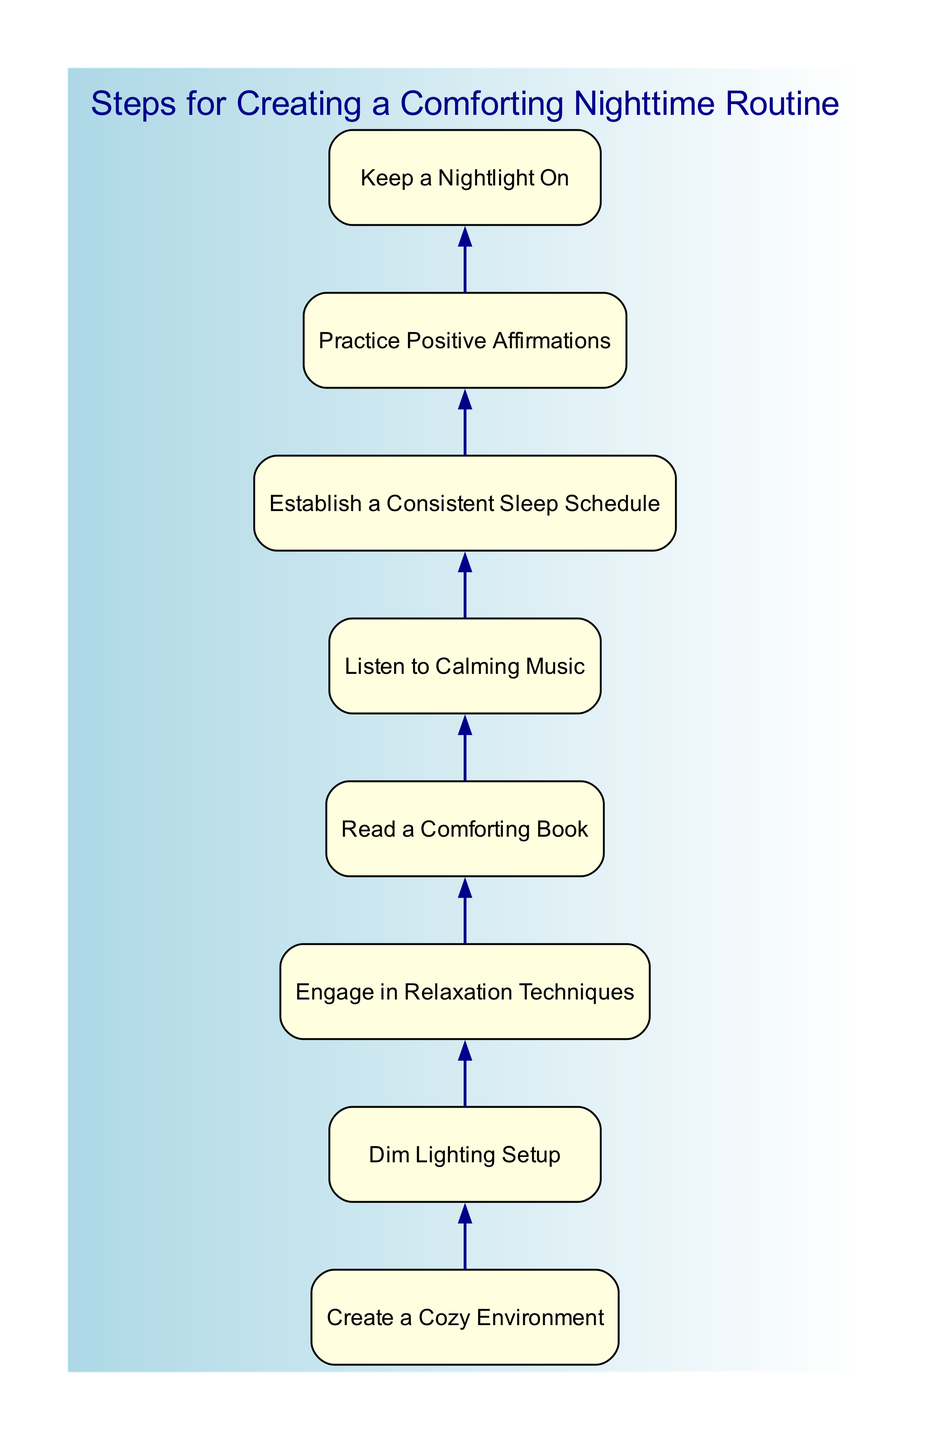What is the first step in the nighttime routine? The diagram starts with the node labeled "Create a Cozy Environment," which is the first element in the bottom-up flow chart.
Answer: Create a Cozy Environment How many steps are included in the nighttime routine? Counting all the nodes in the diagram, there are a total of eight steps, each representing a unique aspect of the nighttime routine.
Answer: 8 What follows the "Dim Lighting Setup"? In the flow chart, the node "Engage in Relaxation Techniques" directly follows the node "Dim Lighting Setup," indicating the next step after adjusting the lighting.
Answer: Engage in Relaxation Techniques Which node suggests using a nightlight? The diagram contains the node "Keep a Nightlight On," which is specifically focused on mitigating fears of the dark by using soft lighting during the night.
Answer: Keep a Nightlight On Which two steps are suggested before listening to calming music? The flow of the chart shows that "Engage in Relaxation Techniques" and "Read a Comforting Book" are the two steps that precede "Listen to Calming Music," providing a sequence of calming actions.
Answer: Engage in Relaxation Techniques, Read a Comforting Book What is the last step indicated in the routine? The final node in the bottom-up flow chart is "Establish a Consistent Sleep Schedule," marking the conclusion of the recommended nighttime routine steps.
Answer: Establish a Consistent Sleep Schedule Which step is directly connected to practicing positive affirmations? The node "Practice Positive Affirmations" is directly linked to the preceding step "Listen to Calming Music," showing the sequence where the affirmations are practiced after listening to music.
Answer: Listen to Calming Music How many edges are present in the diagram? Each step has a direct connection to the next, and since there are eight nodes, there are a total of seven edges connecting these steps in the flow chart.
Answer: 7 